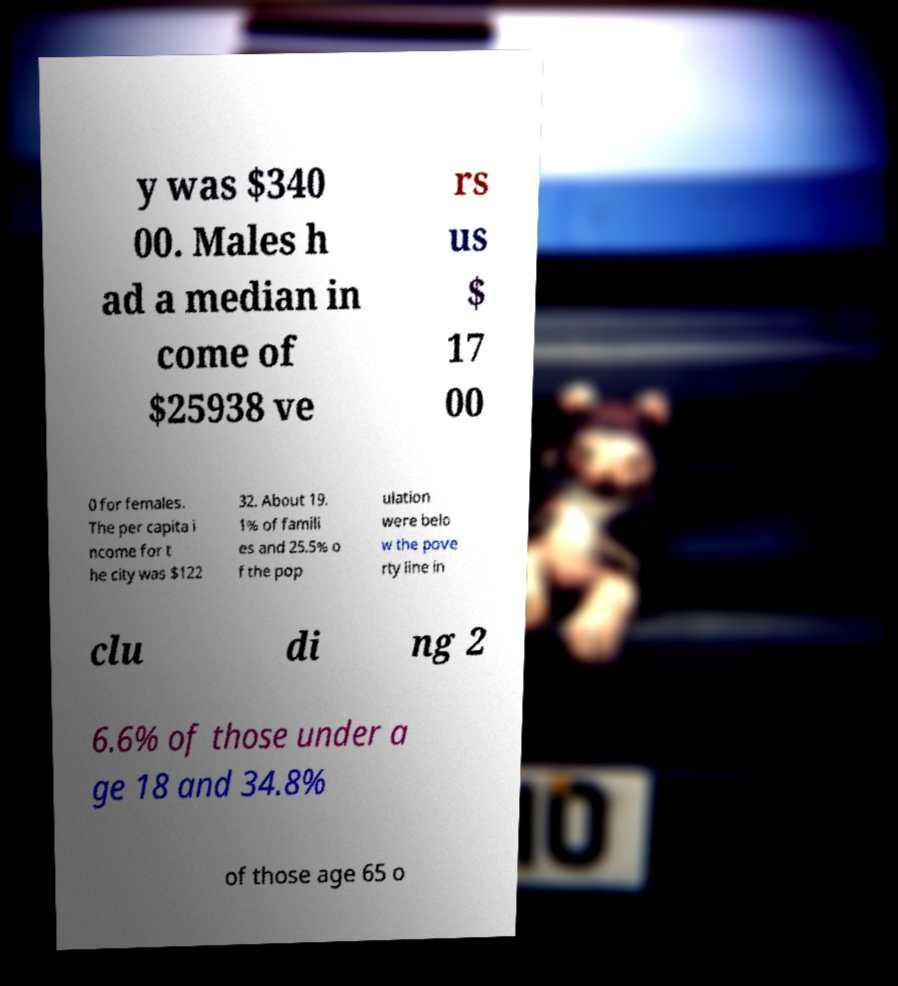Please read and relay the text visible in this image. What does it say? y was $340 00. Males h ad a median in come of $25938 ve rs us $ 17 00 0 for females. The per capita i ncome for t he city was $122 32. About 19. 1% of famili es and 25.5% o f the pop ulation were belo w the pove rty line in clu di ng 2 6.6% of those under a ge 18 and 34.8% of those age 65 o 